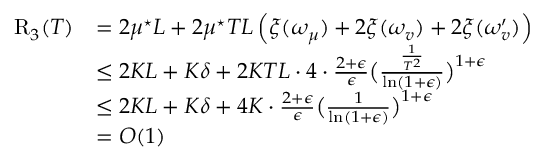<formula> <loc_0><loc_0><loc_500><loc_500>\begin{array} { r l } { R _ { 3 } ( T ) } & { = 2 \mu ^ { ^ { * } } L + 2 \mu ^ { ^ { * } } T L \left ( \xi ( \omega _ { \mu } ) + 2 \xi ( \omega _ { v } ) + 2 \xi ( \omega _ { v } ^ { \prime } ) \right ) } \\ & { \leq 2 K L + K \delta + 2 K T L \cdot 4 \cdot \frac { 2 + \epsilon } { \epsilon } \left ( \frac { \frac { 1 } { T ^ { 2 } } } { \ln ( 1 + \epsilon ) } \right ) ^ { 1 + \epsilon } } \\ & { \leq 2 K L + K \delta + 4 K \cdot \frac { 2 + \epsilon } { \epsilon } \left ( \frac { 1 } { \ln ( 1 + \epsilon ) } \right ) ^ { 1 + \epsilon } } \\ & { = O ( 1 ) } \end{array}</formula> 